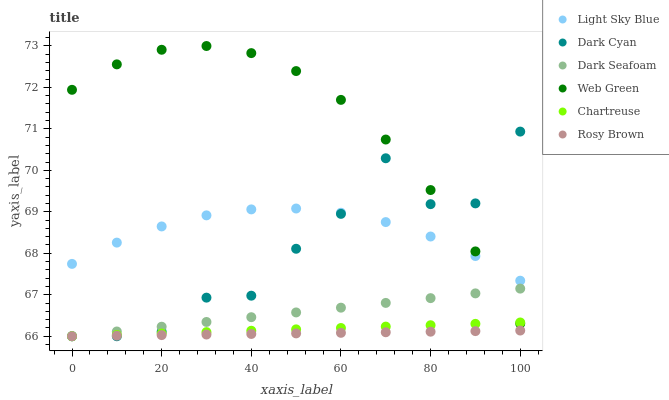Does Rosy Brown have the minimum area under the curve?
Answer yes or no. Yes. Does Web Green have the maximum area under the curve?
Answer yes or no. Yes. Does Chartreuse have the minimum area under the curve?
Answer yes or no. No. Does Chartreuse have the maximum area under the curve?
Answer yes or no. No. Is Chartreuse the smoothest?
Answer yes or no. Yes. Is Dark Cyan the roughest?
Answer yes or no. Yes. Is Web Green the smoothest?
Answer yes or no. No. Is Web Green the roughest?
Answer yes or no. No. Does Rosy Brown have the lowest value?
Answer yes or no. Yes. Does Web Green have the lowest value?
Answer yes or no. No. Does Web Green have the highest value?
Answer yes or no. Yes. Does Chartreuse have the highest value?
Answer yes or no. No. Is Rosy Brown less than Web Green?
Answer yes or no. Yes. Is Light Sky Blue greater than Dark Seafoam?
Answer yes or no. Yes. Does Rosy Brown intersect Dark Cyan?
Answer yes or no. Yes. Is Rosy Brown less than Dark Cyan?
Answer yes or no. No. Is Rosy Brown greater than Dark Cyan?
Answer yes or no. No. Does Rosy Brown intersect Web Green?
Answer yes or no. No. 